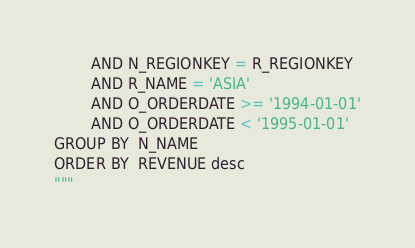<code> <loc_0><loc_0><loc_500><loc_500><_Python_>		AND N_REGIONKEY = R_REGIONKEY
		AND R_NAME = 'ASIA'
		AND O_ORDERDATE >= '1994-01-01'
		AND O_ORDERDATE < '1995-01-01'
GROUP BY  N_NAME
ORDER BY  REVENUE desc
"""
</code> 